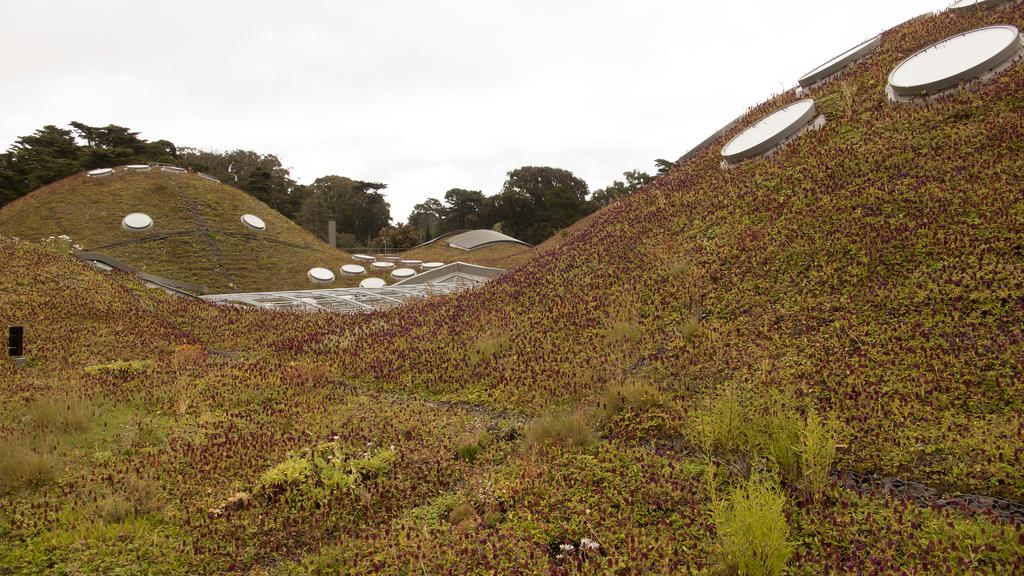What can be seen in the background of the image? The sky is visible in the background of the image. What type of vegetation is present in the image? There are trees and plants in the image. What else can be found in the image besides vegetation? There are objects in the image. Can you describe the terrain in the image? There are inclined grass surfaces in the image. How many cabbages are visible in the image? There are no cabbages present in the image. What type of army is depicted in the image? There is no army depicted in the image. 